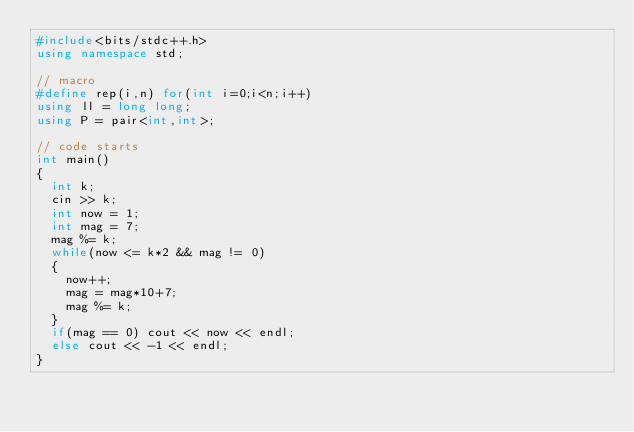<code> <loc_0><loc_0><loc_500><loc_500><_C++_>#include<bits/stdc++.h>
using namespace std;

// macro
#define rep(i,n) for(int i=0;i<n;i++)
using ll = long long;
using P = pair<int,int>;

// code starts
int main()
{
  int k;
  cin >> k;
  int now = 1;
  int mag = 7;
  mag %= k;
  while(now <= k*2 && mag != 0)
  {
    now++;
    mag = mag*10+7;
    mag %= k;
  }
  if(mag == 0) cout << now << endl;
  else cout << -1 << endl;
}
</code> 